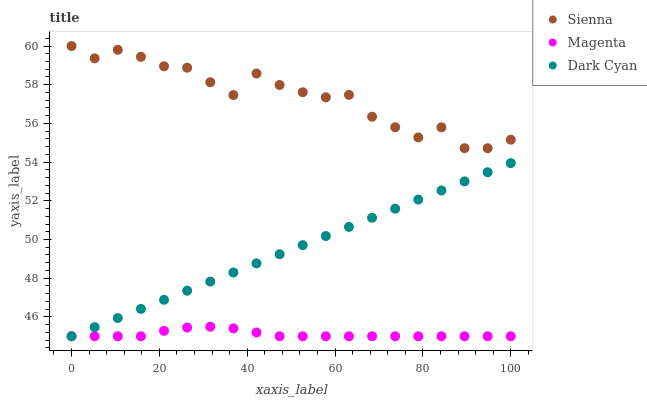Does Magenta have the minimum area under the curve?
Answer yes or no. Yes. Does Sienna have the maximum area under the curve?
Answer yes or no. Yes. Does Dark Cyan have the minimum area under the curve?
Answer yes or no. No. Does Dark Cyan have the maximum area under the curve?
Answer yes or no. No. Is Dark Cyan the smoothest?
Answer yes or no. Yes. Is Sienna the roughest?
Answer yes or no. Yes. Is Magenta the smoothest?
Answer yes or no. No. Is Magenta the roughest?
Answer yes or no. No. Does Dark Cyan have the lowest value?
Answer yes or no. Yes. Does Sienna have the highest value?
Answer yes or no. Yes. Does Dark Cyan have the highest value?
Answer yes or no. No. Is Magenta less than Sienna?
Answer yes or no. Yes. Is Sienna greater than Dark Cyan?
Answer yes or no. Yes. Does Dark Cyan intersect Magenta?
Answer yes or no. Yes. Is Dark Cyan less than Magenta?
Answer yes or no. No. Is Dark Cyan greater than Magenta?
Answer yes or no. No. Does Magenta intersect Sienna?
Answer yes or no. No. 